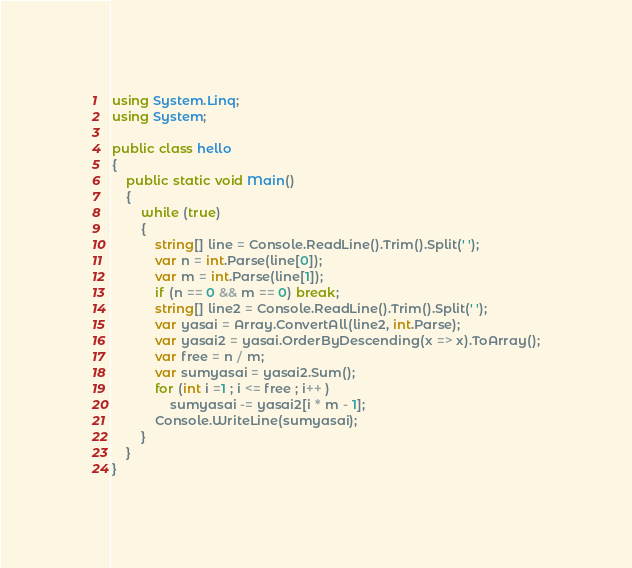<code> <loc_0><loc_0><loc_500><loc_500><_C#_>using System.Linq;
using System;

public class hello
{
    public static void Main()
    {
        while (true)
        {
            string[] line = Console.ReadLine().Trim().Split(' ');
            var n = int.Parse(line[0]);
            var m = int.Parse(line[1]);
            if (n == 0 && m == 0) break;
            string[] line2 = Console.ReadLine().Trim().Split(' ');
            var yasai = Array.ConvertAll(line2, int.Parse);
            var yasai2 = yasai.OrderByDescending(x => x).ToArray();
            var free = n / m;
            var sumyasai = yasai2.Sum();
            for (int i =1 ; i <= free ; i++ )
                sumyasai -= yasai2[i * m - 1];
            Console.WriteLine(sumyasai);
        }
    }
}</code> 